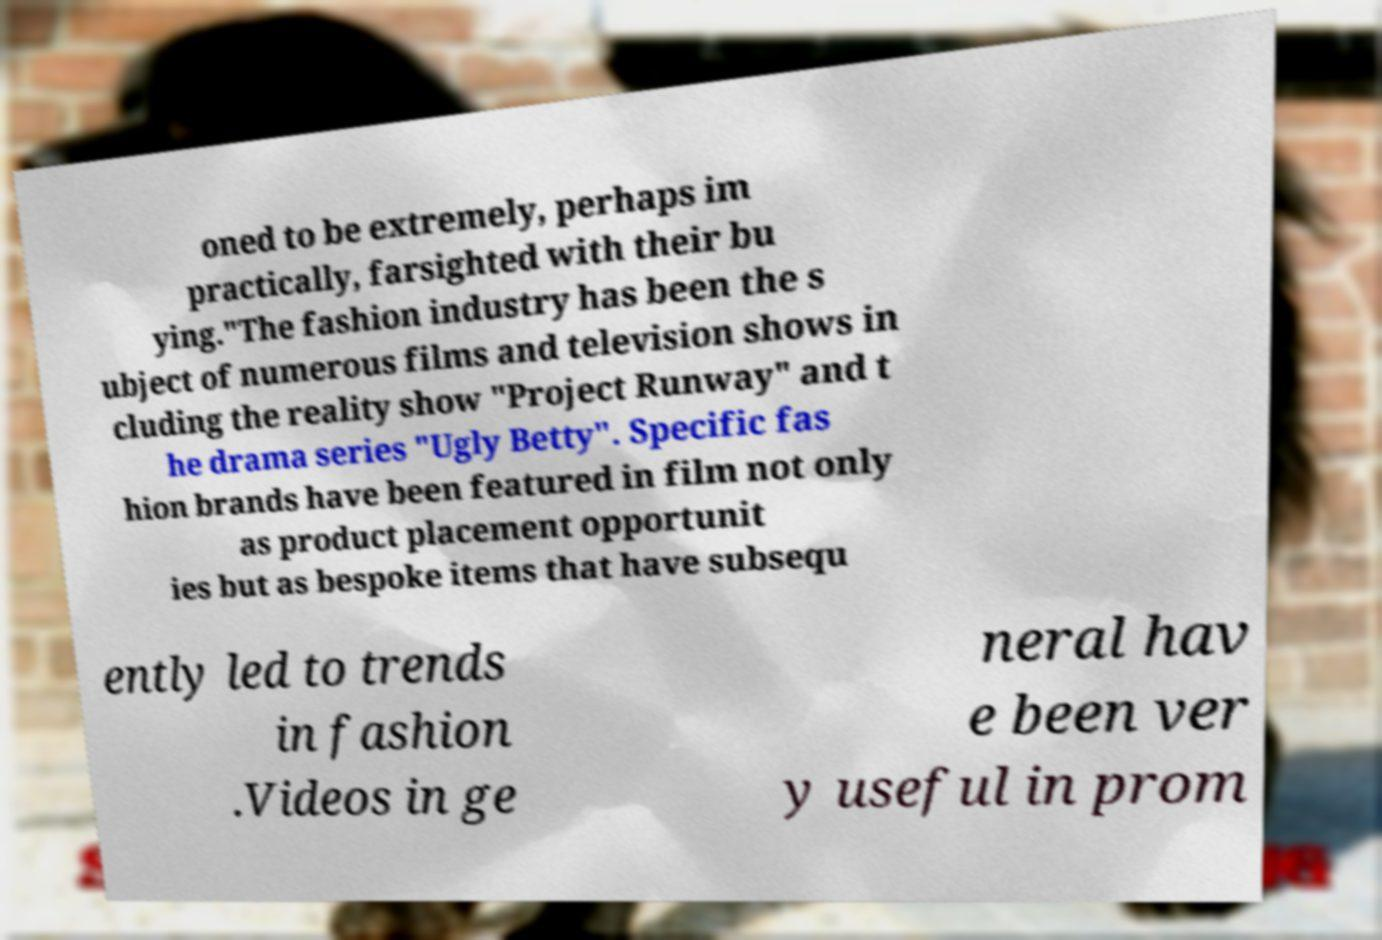Could you assist in decoding the text presented in this image and type it out clearly? oned to be extremely, perhaps im practically, farsighted with their bu ying."The fashion industry has been the s ubject of numerous films and television shows in cluding the reality show "Project Runway" and t he drama series "Ugly Betty". Specific fas hion brands have been featured in film not only as product placement opportunit ies but as bespoke items that have subsequ ently led to trends in fashion .Videos in ge neral hav e been ver y useful in prom 